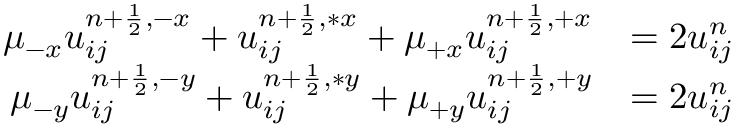<formula> <loc_0><loc_0><loc_500><loc_500>\begin{array} { r l } { \mu _ { - x } u _ { i j } ^ { { n + \frac { 1 } { 2 } } , - x } + u _ { i j } ^ { n + \frac { 1 } { 2 } , \ast x } + \mu _ { + x } u _ { i j } ^ { { n + \frac { 1 } { 2 } } , + x } } & { = 2 u _ { i j } ^ { n } } \\ { \mu _ { - y } u _ { i j } ^ { { n + \frac { 1 } { 2 } } , - y } + u _ { i j } ^ { n + \frac { 1 } { 2 } , \ast y } + \mu _ { + y } u _ { i j } ^ { { n + \frac { 1 } { 2 } } , + y } } & { = 2 u _ { i j } ^ { n } } \end{array}</formula> 